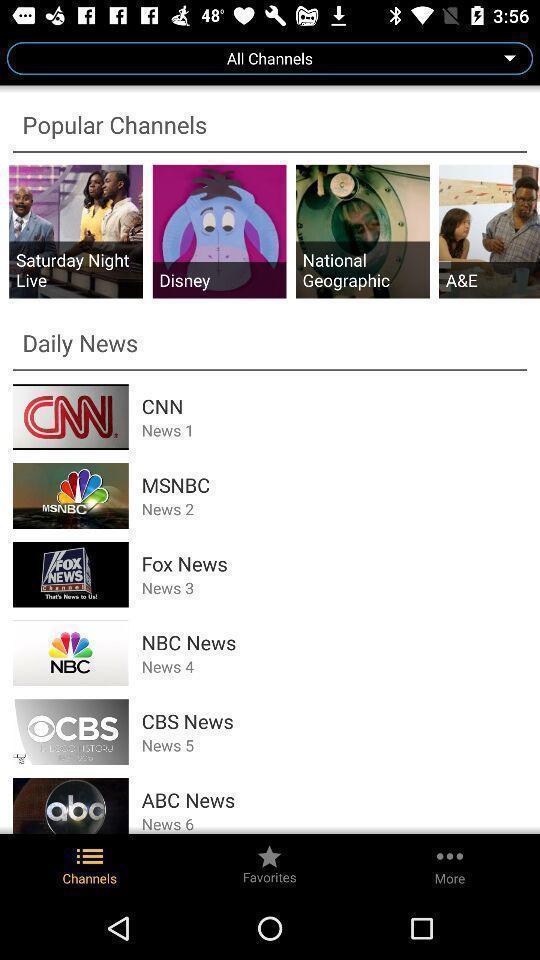Give me a summary of this screen capture. Screen displaying the page with list of popular channels. 